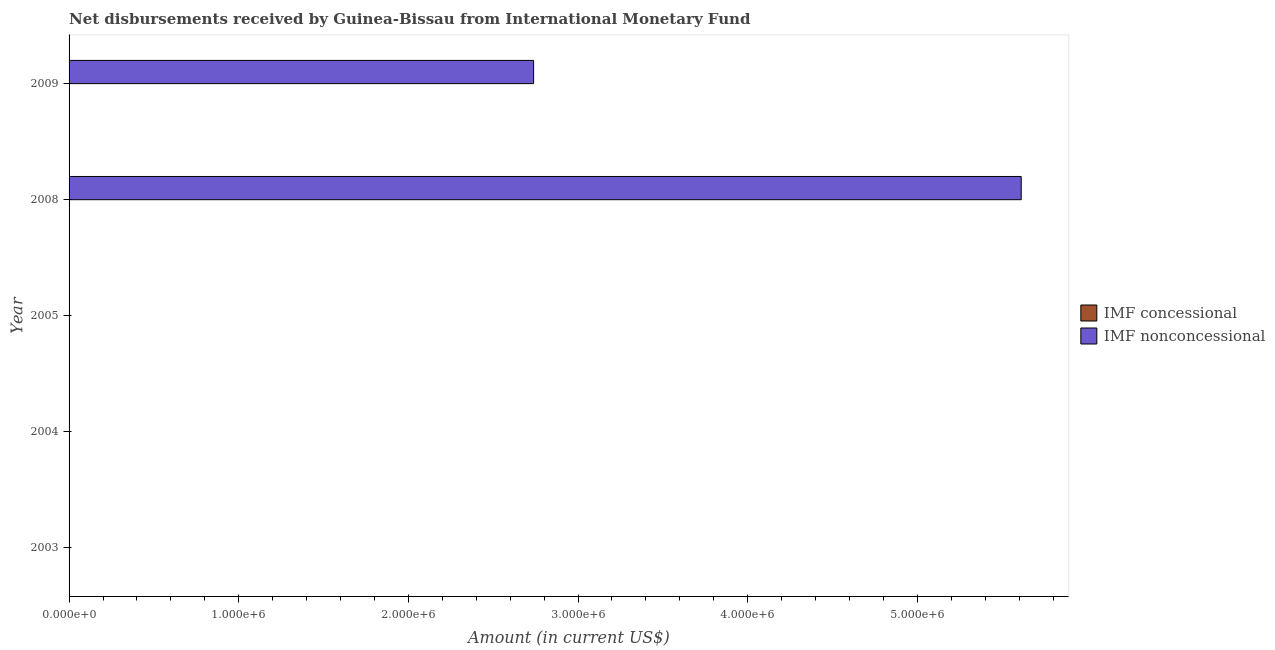Are the number of bars per tick equal to the number of legend labels?
Ensure brevity in your answer.  No. Are the number of bars on each tick of the Y-axis equal?
Keep it short and to the point. No. How many bars are there on the 1st tick from the top?
Your answer should be compact. 1. How many bars are there on the 3rd tick from the bottom?
Your response must be concise. 0. What is the label of the 1st group of bars from the top?
Offer a very short reply. 2009. In how many cases, is the number of bars for a given year not equal to the number of legend labels?
Your answer should be compact. 5. Across all years, what is the maximum net non concessional disbursements from imf?
Provide a short and direct response. 5.61e+06. Across all years, what is the minimum net concessional disbursements from imf?
Your answer should be very brief. 0. What is the difference between the net non concessional disbursements from imf in 2008 and that in 2009?
Give a very brief answer. 2.87e+06. What is the difference between the net non concessional disbursements from imf in 2009 and the net concessional disbursements from imf in 2005?
Provide a short and direct response. 2.74e+06. What is the average net non concessional disbursements from imf per year?
Make the answer very short. 1.67e+06. What is the difference between the highest and the lowest net non concessional disbursements from imf?
Your answer should be compact. 5.61e+06. In how many years, is the net non concessional disbursements from imf greater than the average net non concessional disbursements from imf taken over all years?
Your answer should be compact. 2. Are all the bars in the graph horizontal?
Your answer should be compact. Yes. How many years are there in the graph?
Keep it short and to the point. 5. What is the difference between two consecutive major ticks on the X-axis?
Ensure brevity in your answer.  1.00e+06. Are the values on the major ticks of X-axis written in scientific E-notation?
Give a very brief answer. Yes. How many legend labels are there?
Make the answer very short. 2. What is the title of the graph?
Provide a succinct answer. Net disbursements received by Guinea-Bissau from International Monetary Fund. What is the label or title of the X-axis?
Provide a short and direct response. Amount (in current US$). What is the label or title of the Y-axis?
Provide a succinct answer. Year. What is the Amount (in current US$) in IMF nonconcessional in 2003?
Provide a succinct answer. 0. What is the Amount (in current US$) in IMF concessional in 2008?
Your response must be concise. 0. What is the Amount (in current US$) in IMF nonconcessional in 2008?
Offer a terse response. 5.61e+06. What is the Amount (in current US$) in IMF nonconcessional in 2009?
Your response must be concise. 2.74e+06. Across all years, what is the maximum Amount (in current US$) in IMF nonconcessional?
Keep it short and to the point. 5.61e+06. Across all years, what is the minimum Amount (in current US$) of IMF nonconcessional?
Give a very brief answer. 0. What is the total Amount (in current US$) in IMF concessional in the graph?
Provide a short and direct response. 0. What is the total Amount (in current US$) in IMF nonconcessional in the graph?
Ensure brevity in your answer.  8.35e+06. What is the difference between the Amount (in current US$) of IMF nonconcessional in 2008 and that in 2009?
Keep it short and to the point. 2.87e+06. What is the average Amount (in current US$) of IMF concessional per year?
Make the answer very short. 0. What is the average Amount (in current US$) in IMF nonconcessional per year?
Offer a very short reply. 1.67e+06. What is the ratio of the Amount (in current US$) in IMF nonconcessional in 2008 to that in 2009?
Your answer should be very brief. 2.05. What is the difference between the highest and the lowest Amount (in current US$) in IMF nonconcessional?
Your response must be concise. 5.61e+06. 